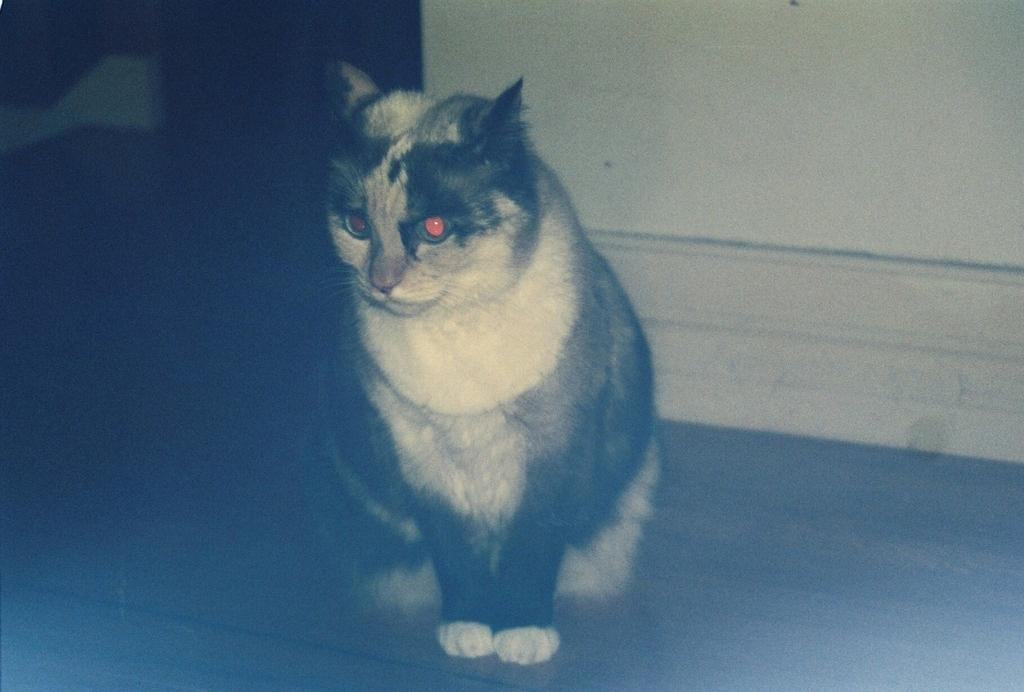What type of animal is in the image? There is a cat in the image. Where is the cat located in the image? The cat is on the floor. What can be seen in the background of the image? There is a wall in the background of the image. What type of humor can be seen in the image? There is no humor present in the image; it features a cat on the floor with a wall in the background. 